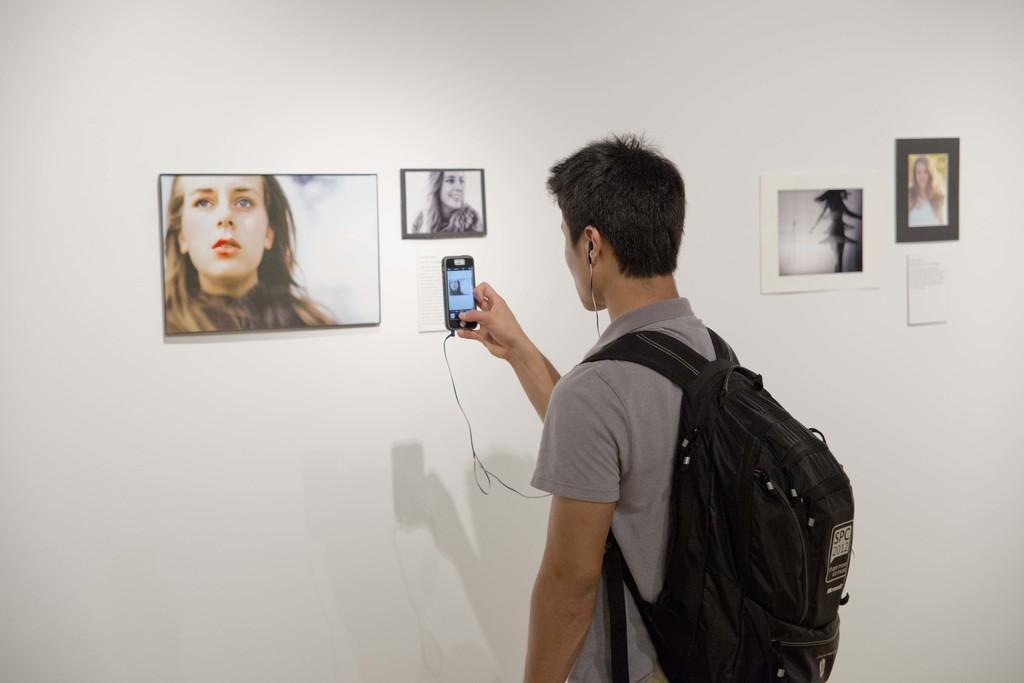What is the person in the image doing? The person is taking a photo. What is the person carrying in the image? The person is carrying a backpack. What is the person wearing in the image? The person is wearing headphones. What can be seen on the wall in the image? There is a painting on the wall. What type of lace is being used to secure the painting on the wall in the image? There is no lace visible in the image, and the painting is not secured to the wall. 